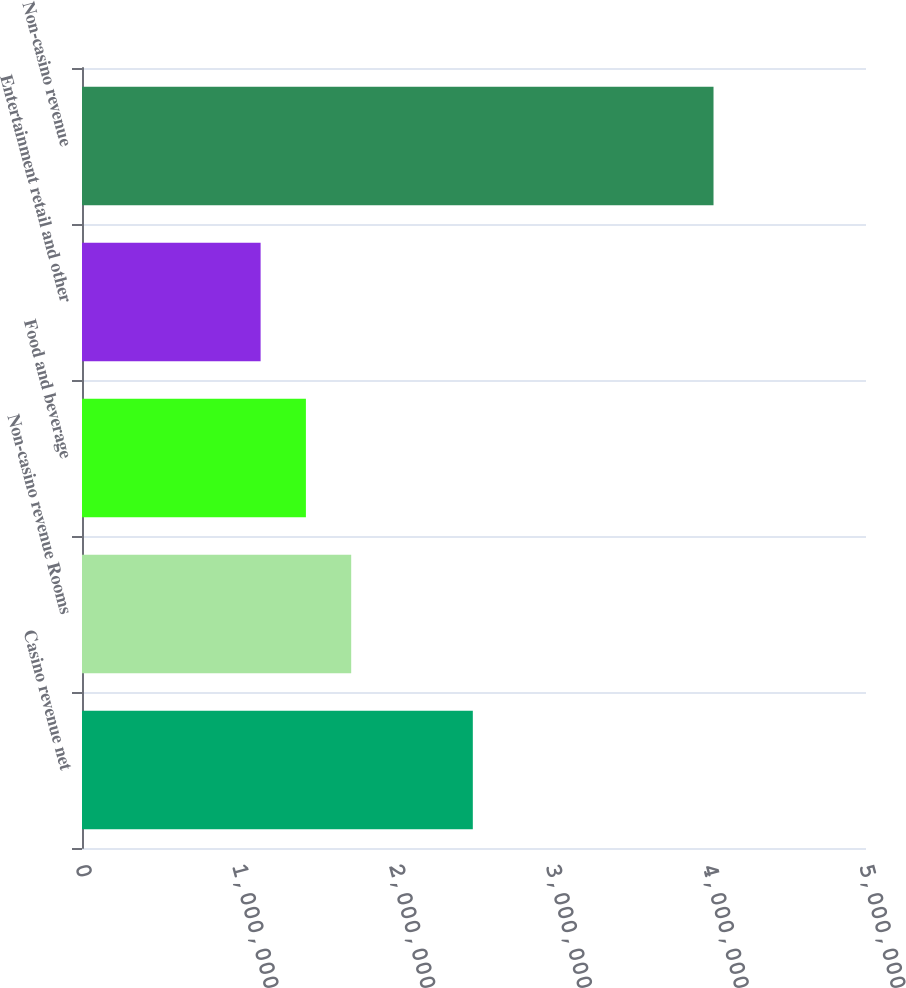<chart> <loc_0><loc_0><loc_500><loc_500><bar_chart><fcel>Casino revenue net<fcel>Non-casino revenue Rooms<fcel>Food and beverage<fcel>Entertainment retail and other<fcel>Non-casino revenue<nl><fcel>2.49247e+06<fcel>1.71682e+06<fcel>1.42798e+06<fcel>1.13914e+06<fcel>4.02754e+06<nl></chart> 